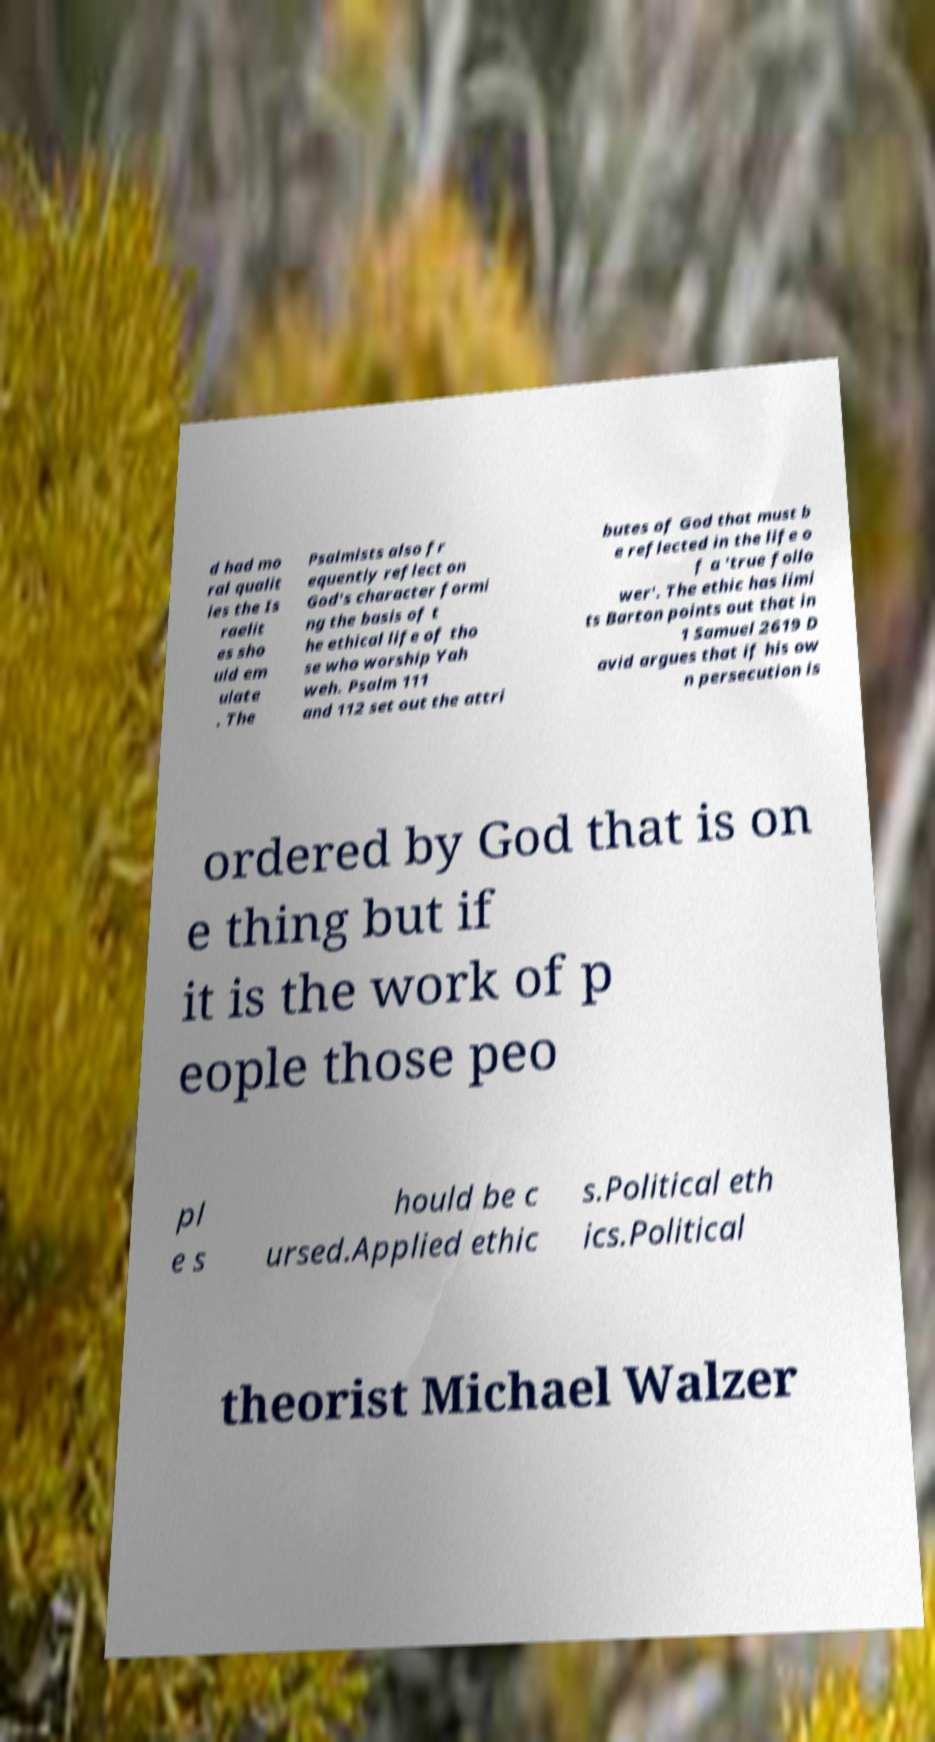Please identify and transcribe the text found in this image. d had mo ral qualit ies the Is raelit es sho uld em ulate . The Psalmists also fr equently reflect on God's character formi ng the basis of t he ethical life of tho se who worship Yah weh. Psalm 111 and 112 set out the attri butes of God that must b e reflected in the life o f a 'true follo wer'. The ethic has limi ts Barton points out that in 1 Samuel 2619 D avid argues that if his ow n persecution is ordered by God that is on e thing but if it is the work of p eople those peo pl e s hould be c ursed.Applied ethic s.Political eth ics.Political theorist Michael Walzer 